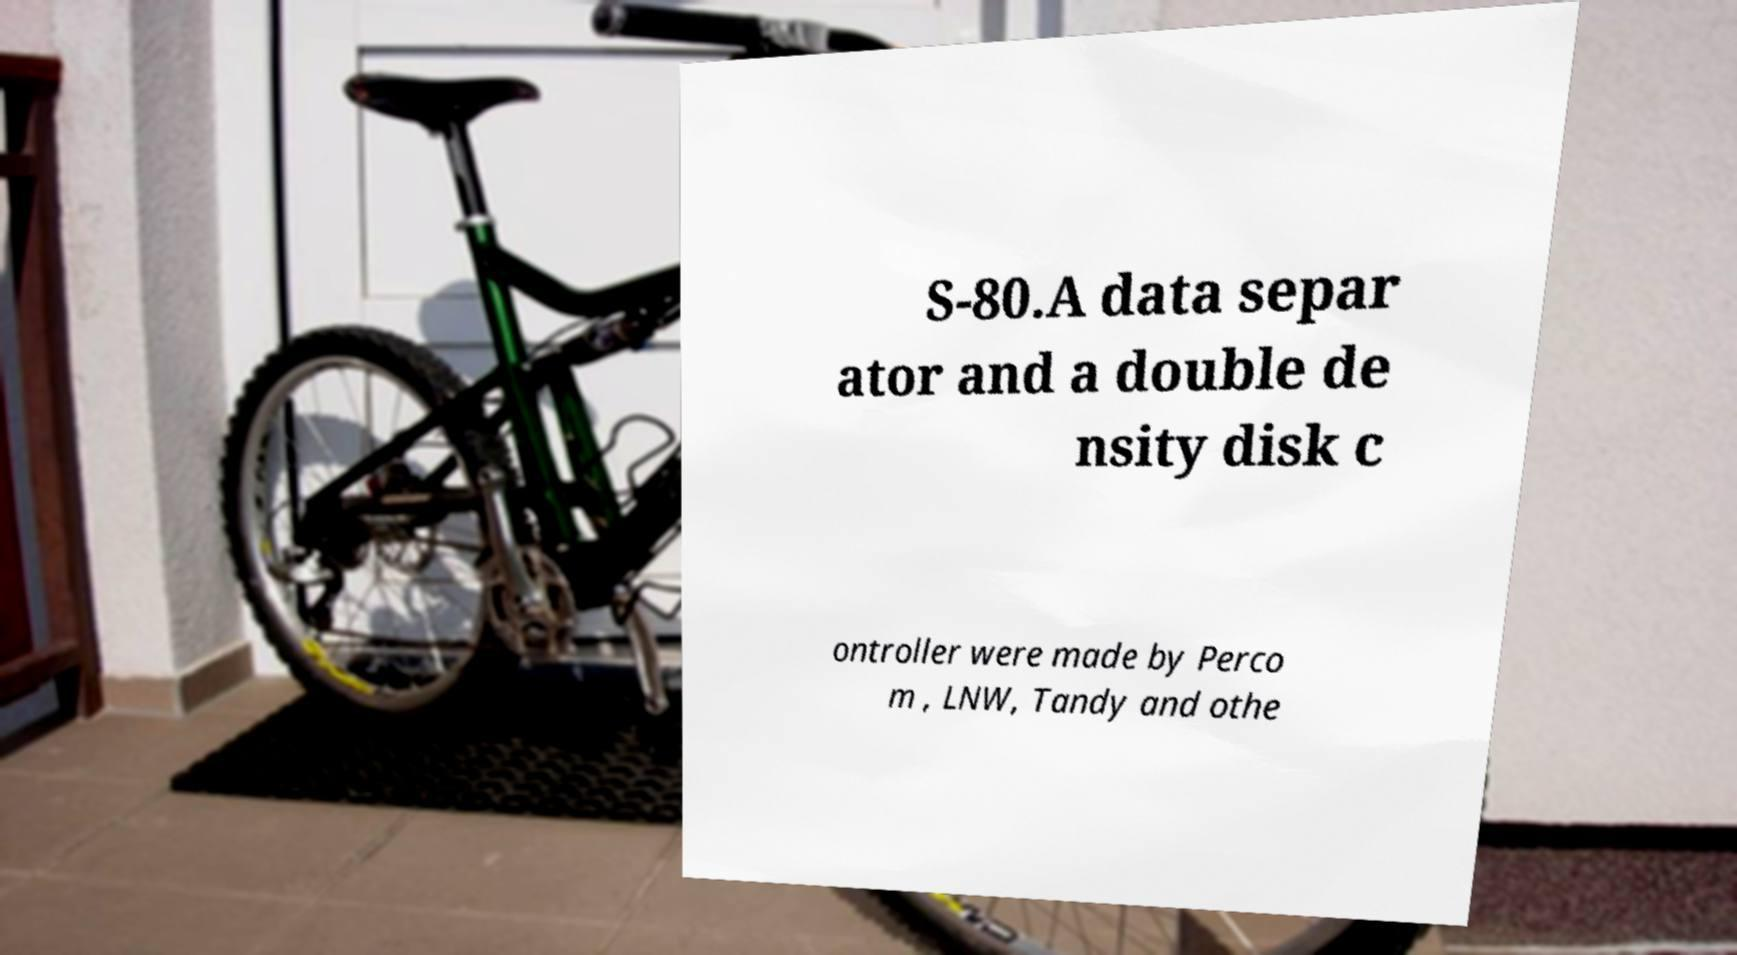Can you read and provide the text displayed in the image?This photo seems to have some interesting text. Can you extract and type it out for me? S-80.A data separ ator and a double de nsity disk c ontroller were made by Perco m , LNW, Tandy and othe 